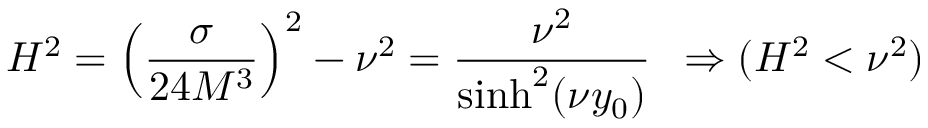Convert formula to latex. <formula><loc_0><loc_0><loc_500><loc_500>H ^ { 2 } = \left ( \frac { \sigma } { 2 4 M ^ { 3 } } \right ) ^ { 2 } - \nu ^ { 2 } = \frac { \nu ^ { 2 } } { \sinh ^ { 2 } ( \nu y _ { 0 } ) } \, \Rightarrow ( H ^ { 2 } < \nu ^ { 2 } )</formula> 